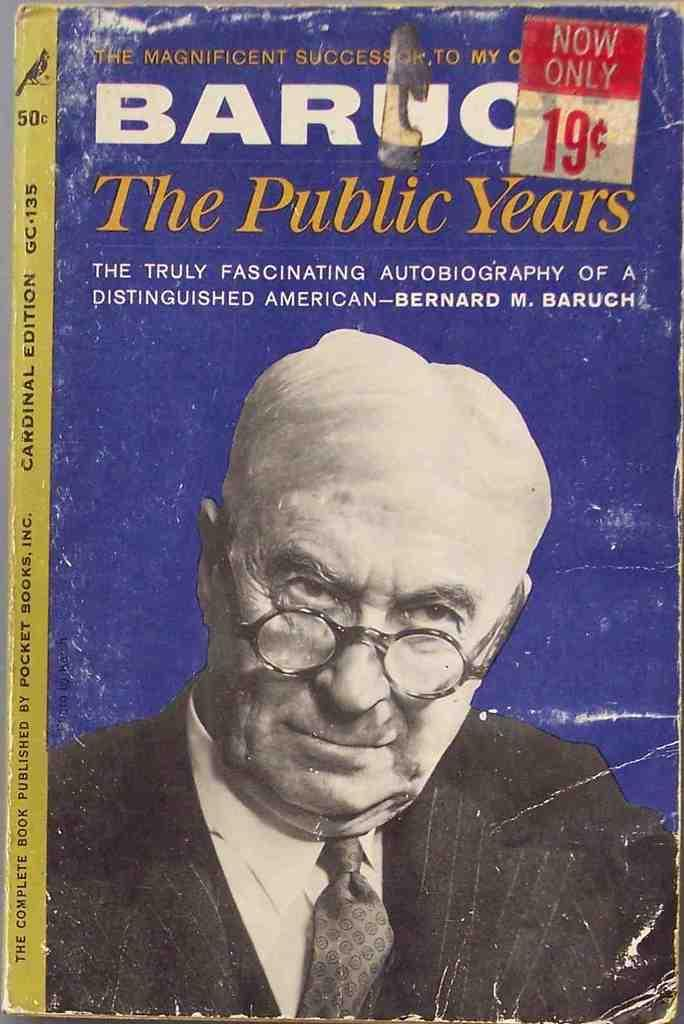What is the main object in the image? There is a book in the image. Can you describe the book's appearance? The book has a blue and yellow cover. What is depicted on the cover page of the book? The cover page features a person wearing spectacles. What type of cord is used to tie the pen on the book's cover? There is no cord or pen present on the book's cover in the image. 